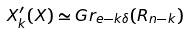Convert formula to latex. <formula><loc_0><loc_0><loc_500><loc_500>X ^ { \prime } _ { k } ( X ) \simeq G r _ { e - k \delta } ( R _ { n - k } )</formula> 